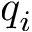Convert formula to latex. <formula><loc_0><loc_0><loc_500><loc_500>q _ { i }</formula> 